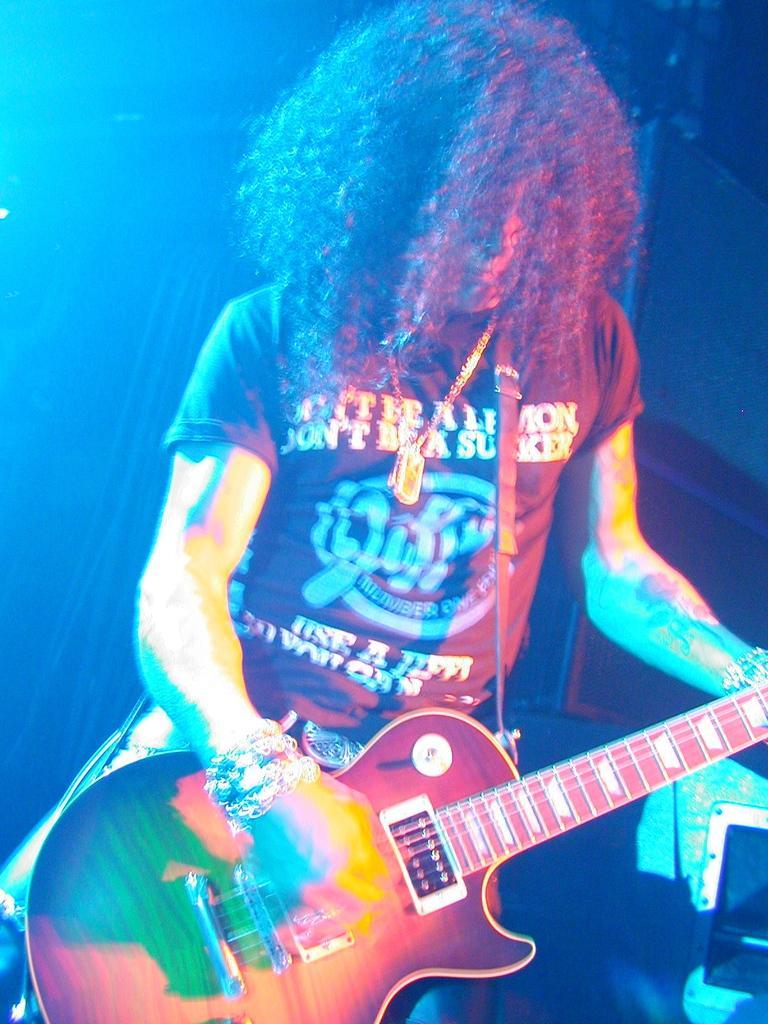How would you summarize this image in a sentence or two? There is a man who is playing guitar. On the right side there is a box. 